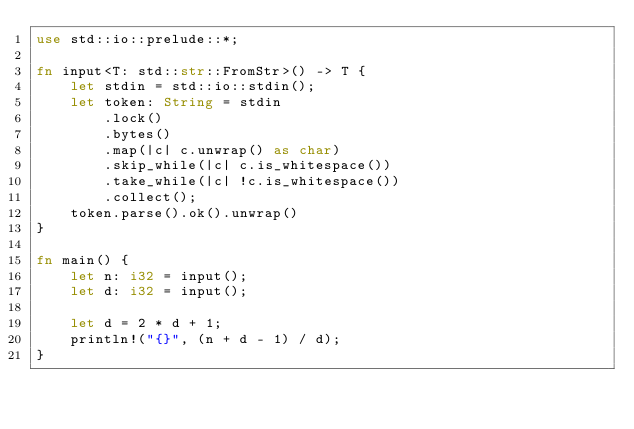<code> <loc_0><loc_0><loc_500><loc_500><_Rust_>use std::io::prelude::*;

fn input<T: std::str::FromStr>() -> T {
    let stdin = std::io::stdin();
    let token: String = stdin
        .lock()
        .bytes()
        .map(|c| c.unwrap() as char)
        .skip_while(|c| c.is_whitespace())
        .take_while(|c| !c.is_whitespace())
        .collect();
    token.parse().ok().unwrap()
}

fn main() {
    let n: i32 = input();
    let d: i32 = input();

    let d = 2 * d + 1;
    println!("{}", (n + d - 1) / d);
}
</code> 